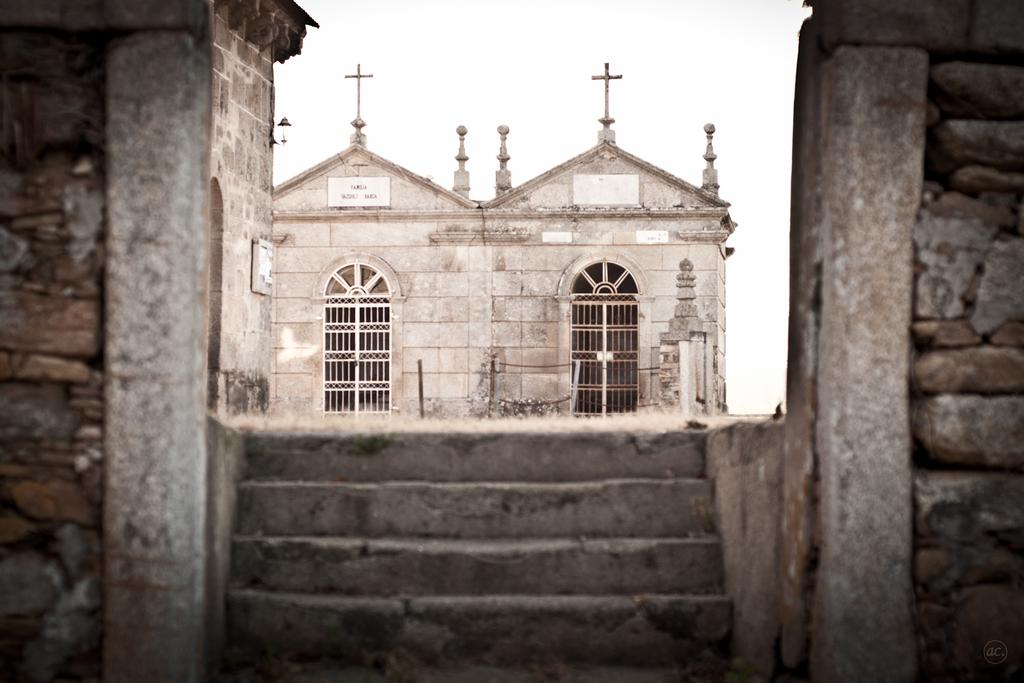What type of building can be seen in the background of the image? There is a church in the background of the image. What type of calculator is being used by the priest in the image? There is no calculator present in the image, and the priest is not performing any actions that would require a calculator. 